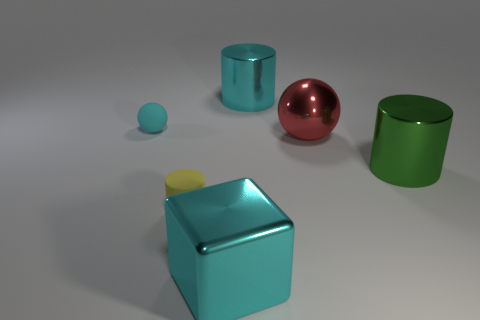There is a cyan object that is to the left of the cyan block; does it have the same size as the cylinder that is left of the large cyan cylinder?
Provide a succinct answer. Yes. What number of other things are the same shape as the yellow rubber thing?
Keep it short and to the point. 2. There is a big cylinder right of the cyan metallic object that is right of the big cube; what is it made of?
Provide a short and direct response. Metal. How many shiny things are either large cyan cubes or big cyan cylinders?
Give a very brief answer. 2. Are there any other things that have the same material as the green cylinder?
Provide a short and direct response. Yes. Are there any large metallic cubes that are on the left side of the small thing that is in front of the green metal object?
Provide a succinct answer. No. How many objects are either big metal cylinders that are in front of the small cyan object or big things in front of the tiny cyan sphere?
Ensure brevity in your answer.  3. Is there anything else of the same color as the small cylinder?
Your answer should be very brief. No. What color is the cylinder to the left of the big metallic thing to the left of the large metallic cylinder behind the big red ball?
Give a very brief answer. Yellow. There is a metal cylinder in front of the big cyan thing that is behind the big shiny cube; what is its size?
Provide a short and direct response. Large. 